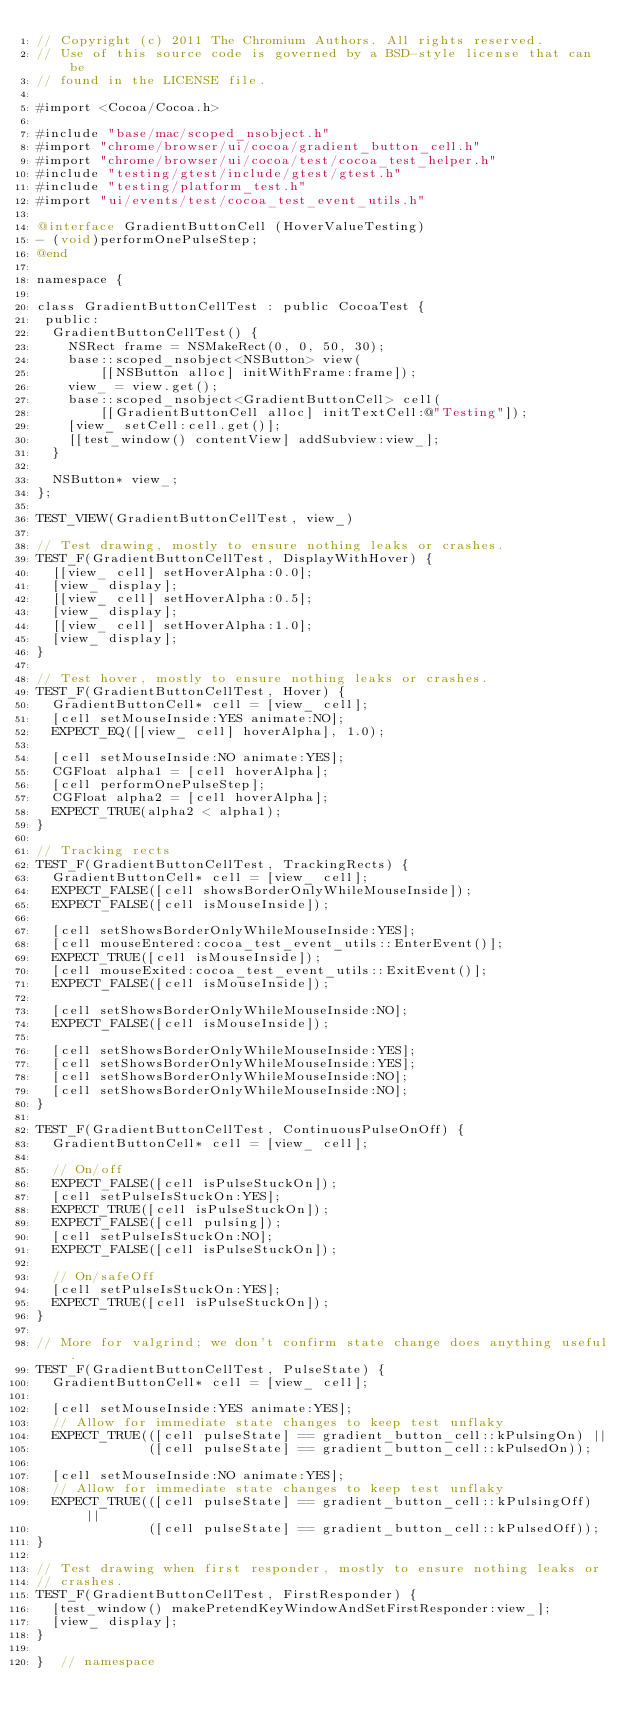Convert code to text. <code><loc_0><loc_0><loc_500><loc_500><_ObjectiveC_>// Copyright (c) 2011 The Chromium Authors. All rights reserved.
// Use of this source code is governed by a BSD-style license that can be
// found in the LICENSE file.

#import <Cocoa/Cocoa.h>

#include "base/mac/scoped_nsobject.h"
#import "chrome/browser/ui/cocoa/gradient_button_cell.h"
#import "chrome/browser/ui/cocoa/test/cocoa_test_helper.h"
#include "testing/gtest/include/gtest/gtest.h"
#include "testing/platform_test.h"
#import "ui/events/test/cocoa_test_event_utils.h"

@interface GradientButtonCell (HoverValueTesting)
- (void)performOnePulseStep;
@end

namespace {

class GradientButtonCellTest : public CocoaTest {
 public:
  GradientButtonCellTest() {
    NSRect frame = NSMakeRect(0, 0, 50, 30);
    base::scoped_nsobject<NSButton> view(
        [[NSButton alloc] initWithFrame:frame]);
    view_ = view.get();
    base::scoped_nsobject<GradientButtonCell> cell(
        [[GradientButtonCell alloc] initTextCell:@"Testing"]);
    [view_ setCell:cell.get()];
    [[test_window() contentView] addSubview:view_];
  }

  NSButton* view_;
};

TEST_VIEW(GradientButtonCellTest, view_)

// Test drawing, mostly to ensure nothing leaks or crashes.
TEST_F(GradientButtonCellTest, DisplayWithHover) {
  [[view_ cell] setHoverAlpha:0.0];
  [view_ display];
  [[view_ cell] setHoverAlpha:0.5];
  [view_ display];
  [[view_ cell] setHoverAlpha:1.0];
  [view_ display];
}

// Test hover, mostly to ensure nothing leaks or crashes.
TEST_F(GradientButtonCellTest, Hover) {
  GradientButtonCell* cell = [view_ cell];
  [cell setMouseInside:YES animate:NO];
  EXPECT_EQ([[view_ cell] hoverAlpha], 1.0);

  [cell setMouseInside:NO animate:YES];
  CGFloat alpha1 = [cell hoverAlpha];
  [cell performOnePulseStep];
  CGFloat alpha2 = [cell hoverAlpha];
  EXPECT_TRUE(alpha2 < alpha1);
}

// Tracking rects
TEST_F(GradientButtonCellTest, TrackingRects) {
  GradientButtonCell* cell = [view_ cell];
  EXPECT_FALSE([cell showsBorderOnlyWhileMouseInside]);
  EXPECT_FALSE([cell isMouseInside]);

  [cell setShowsBorderOnlyWhileMouseInside:YES];
  [cell mouseEntered:cocoa_test_event_utils::EnterEvent()];
  EXPECT_TRUE([cell isMouseInside]);
  [cell mouseExited:cocoa_test_event_utils::ExitEvent()];
  EXPECT_FALSE([cell isMouseInside]);

  [cell setShowsBorderOnlyWhileMouseInside:NO];
  EXPECT_FALSE([cell isMouseInside]);

  [cell setShowsBorderOnlyWhileMouseInside:YES];
  [cell setShowsBorderOnlyWhileMouseInside:YES];
  [cell setShowsBorderOnlyWhileMouseInside:NO];
  [cell setShowsBorderOnlyWhileMouseInside:NO];
}

TEST_F(GradientButtonCellTest, ContinuousPulseOnOff) {
  GradientButtonCell* cell = [view_ cell];

  // On/off
  EXPECT_FALSE([cell isPulseStuckOn]);
  [cell setPulseIsStuckOn:YES];
  EXPECT_TRUE([cell isPulseStuckOn]);
  EXPECT_FALSE([cell pulsing]);
  [cell setPulseIsStuckOn:NO];
  EXPECT_FALSE([cell isPulseStuckOn]);

  // On/safeOff
  [cell setPulseIsStuckOn:YES];
  EXPECT_TRUE([cell isPulseStuckOn]);
}

// More for valgrind; we don't confirm state change does anything useful.
TEST_F(GradientButtonCellTest, PulseState) {
  GradientButtonCell* cell = [view_ cell];

  [cell setMouseInside:YES animate:YES];
  // Allow for immediate state changes to keep test unflaky
  EXPECT_TRUE(([cell pulseState] == gradient_button_cell::kPulsingOn) ||
              ([cell pulseState] == gradient_button_cell::kPulsedOn));

  [cell setMouseInside:NO animate:YES];
  // Allow for immediate state changes to keep test unflaky
  EXPECT_TRUE(([cell pulseState] == gradient_button_cell::kPulsingOff) ||
              ([cell pulseState] == gradient_button_cell::kPulsedOff));
}

// Test drawing when first responder, mostly to ensure nothing leaks or
// crashes.
TEST_F(GradientButtonCellTest, FirstResponder) {
  [test_window() makePretendKeyWindowAndSetFirstResponder:view_];
  [view_ display];
}

}  // namespace
</code> 